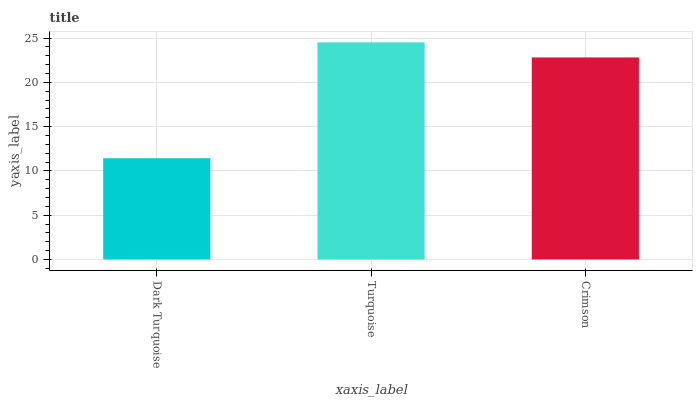Is Crimson the minimum?
Answer yes or no. No. Is Crimson the maximum?
Answer yes or no. No. Is Turquoise greater than Crimson?
Answer yes or no. Yes. Is Crimson less than Turquoise?
Answer yes or no. Yes. Is Crimson greater than Turquoise?
Answer yes or no. No. Is Turquoise less than Crimson?
Answer yes or no. No. Is Crimson the high median?
Answer yes or no. Yes. Is Crimson the low median?
Answer yes or no. Yes. Is Turquoise the high median?
Answer yes or no. No. Is Dark Turquoise the low median?
Answer yes or no. No. 